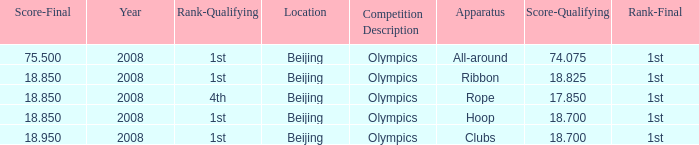On which apparatus did Kanayeva have a final score smaller than 75.5 and a qualifying score smaller than 18.7? Rope. 